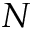Convert formula to latex. <formula><loc_0><loc_0><loc_500><loc_500>N</formula> 